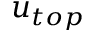Convert formula to latex. <formula><loc_0><loc_0><loc_500><loc_500>{ u } _ { t o p }</formula> 